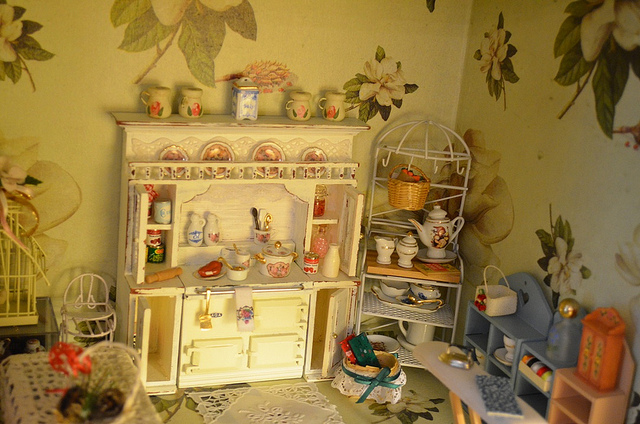What could be the possible theme or inspiration for this miniature setup? The setting seems to draw inspiration from a rustic or countryside kitchen, capturing the essence of a homely and quaint environment. The choice of elements and their arrangement suggests a love for traditional home decor, possibly hinting at a historical period inspiration or just the creator's own intricate imagination. 